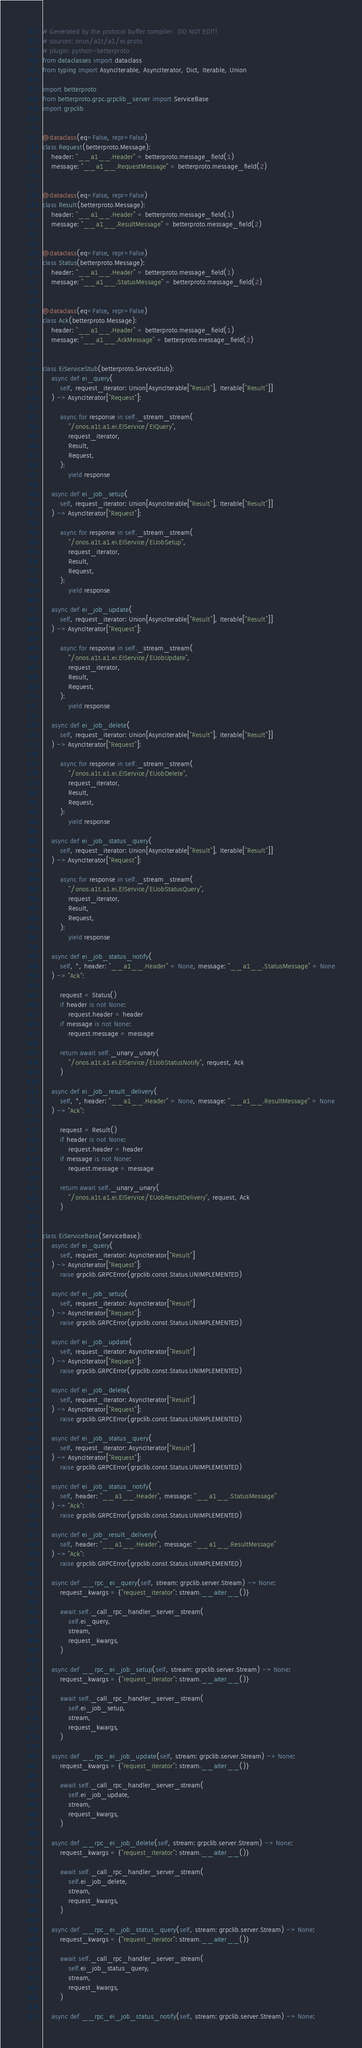Convert code to text. <code><loc_0><loc_0><loc_500><loc_500><_Python_># Generated by the protocol buffer compiler.  DO NOT EDIT!
# sources: onos/a1t/a1/ei.proto
# plugin: python-betterproto
from dataclasses import dataclass
from typing import AsyncIterable, AsyncIterator, Dict, Iterable, Union

import betterproto
from betterproto.grpc.grpclib_server import ServiceBase
import grpclib


@dataclass(eq=False, repr=False)
class Request(betterproto.Message):
    header: "__a1__.Header" = betterproto.message_field(1)
    message: "__a1__.RequestMessage" = betterproto.message_field(2)


@dataclass(eq=False, repr=False)
class Result(betterproto.Message):
    header: "__a1__.Header" = betterproto.message_field(1)
    message: "__a1__.ResultMessage" = betterproto.message_field(2)


@dataclass(eq=False, repr=False)
class Status(betterproto.Message):
    header: "__a1__.Header" = betterproto.message_field(1)
    message: "__a1__.StatusMessage" = betterproto.message_field(2)


@dataclass(eq=False, repr=False)
class Ack(betterproto.Message):
    header: "__a1__.Header" = betterproto.message_field(1)
    message: "__a1__.AckMessage" = betterproto.message_field(2)


class EiServiceStub(betterproto.ServiceStub):
    async def ei_query(
        self, request_iterator: Union[AsyncIterable["Result"], Iterable["Result"]]
    ) -> AsyncIterator["Request"]:

        async for response in self._stream_stream(
            "/onos.a1t.a1.ei.EIService/EIQuery",
            request_iterator,
            Result,
            Request,
        ):
            yield response

    async def ei_job_setup(
        self, request_iterator: Union[AsyncIterable["Result"], Iterable["Result"]]
    ) -> AsyncIterator["Request"]:

        async for response in self._stream_stream(
            "/onos.a1t.a1.ei.EIService/EIJobSetup",
            request_iterator,
            Result,
            Request,
        ):
            yield response

    async def ei_job_update(
        self, request_iterator: Union[AsyncIterable["Result"], Iterable["Result"]]
    ) -> AsyncIterator["Request"]:

        async for response in self._stream_stream(
            "/onos.a1t.a1.ei.EIService/EIJobUpdate",
            request_iterator,
            Result,
            Request,
        ):
            yield response

    async def ei_job_delete(
        self, request_iterator: Union[AsyncIterable["Result"], Iterable["Result"]]
    ) -> AsyncIterator["Request"]:

        async for response in self._stream_stream(
            "/onos.a1t.a1.ei.EIService/EIJobDelete",
            request_iterator,
            Result,
            Request,
        ):
            yield response

    async def ei_job_status_query(
        self, request_iterator: Union[AsyncIterable["Result"], Iterable["Result"]]
    ) -> AsyncIterator["Request"]:

        async for response in self._stream_stream(
            "/onos.a1t.a1.ei.EIService/EIJobStatusQuery",
            request_iterator,
            Result,
            Request,
        ):
            yield response

    async def ei_job_status_notify(
        self, *, header: "__a1__.Header" = None, message: "__a1__.StatusMessage" = None
    ) -> "Ack":

        request = Status()
        if header is not None:
            request.header = header
        if message is not None:
            request.message = message

        return await self._unary_unary(
            "/onos.a1t.a1.ei.EIService/EIJobStatusNotify", request, Ack
        )

    async def ei_job_result_delivery(
        self, *, header: "__a1__.Header" = None, message: "__a1__.ResultMessage" = None
    ) -> "Ack":

        request = Result()
        if header is not None:
            request.header = header
        if message is not None:
            request.message = message

        return await self._unary_unary(
            "/onos.a1t.a1.ei.EIService/EIJobResultDelivery", request, Ack
        )


class EiServiceBase(ServiceBase):
    async def ei_query(
        self, request_iterator: AsyncIterator["Result"]
    ) -> AsyncIterator["Request"]:
        raise grpclib.GRPCError(grpclib.const.Status.UNIMPLEMENTED)

    async def ei_job_setup(
        self, request_iterator: AsyncIterator["Result"]
    ) -> AsyncIterator["Request"]:
        raise grpclib.GRPCError(grpclib.const.Status.UNIMPLEMENTED)

    async def ei_job_update(
        self, request_iterator: AsyncIterator["Result"]
    ) -> AsyncIterator["Request"]:
        raise grpclib.GRPCError(grpclib.const.Status.UNIMPLEMENTED)

    async def ei_job_delete(
        self, request_iterator: AsyncIterator["Result"]
    ) -> AsyncIterator["Request"]:
        raise grpclib.GRPCError(grpclib.const.Status.UNIMPLEMENTED)

    async def ei_job_status_query(
        self, request_iterator: AsyncIterator["Result"]
    ) -> AsyncIterator["Request"]:
        raise grpclib.GRPCError(grpclib.const.Status.UNIMPLEMENTED)

    async def ei_job_status_notify(
        self, header: "__a1__.Header", message: "__a1__.StatusMessage"
    ) -> "Ack":
        raise grpclib.GRPCError(grpclib.const.Status.UNIMPLEMENTED)

    async def ei_job_result_delivery(
        self, header: "__a1__.Header", message: "__a1__.ResultMessage"
    ) -> "Ack":
        raise grpclib.GRPCError(grpclib.const.Status.UNIMPLEMENTED)

    async def __rpc_ei_query(self, stream: grpclib.server.Stream) -> None:
        request_kwargs = {"request_iterator": stream.__aiter__()}

        await self._call_rpc_handler_server_stream(
            self.ei_query,
            stream,
            request_kwargs,
        )

    async def __rpc_ei_job_setup(self, stream: grpclib.server.Stream) -> None:
        request_kwargs = {"request_iterator": stream.__aiter__()}

        await self._call_rpc_handler_server_stream(
            self.ei_job_setup,
            stream,
            request_kwargs,
        )

    async def __rpc_ei_job_update(self, stream: grpclib.server.Stream) -> None:
        request_kwargs = {"request_iterator": stream.__aiter__()}

        await self._call_rpc_handler_server_stream(
            self.ei_job_update,
            stream,
            request_kwargs,
        )

    async def __rpc_ei_job_delete(self, stream: grpclib.server.Stream) -> None:
        request_kwargs = {"request_iterator": stream.__aiter__()}

        await self._call_rpc_handler_server_stream(
            self.ei_job_delete,
            stream,
            request_kwargs,
        )

    async def __rpc_ei_job_status_query(self, stream: grpclib.server.Stream) -> None:
        request_kwargs = {"request_iterator": stream.__aiter__()}

        await self._call_rpc_handler_server_stream(
            self.ei_job_status_query,
            stream,
            request_kwargs,
        )

    async def __rpc_ei_job_status_notify(self, stream: grpclib.server.Stream) -> None:</code> 